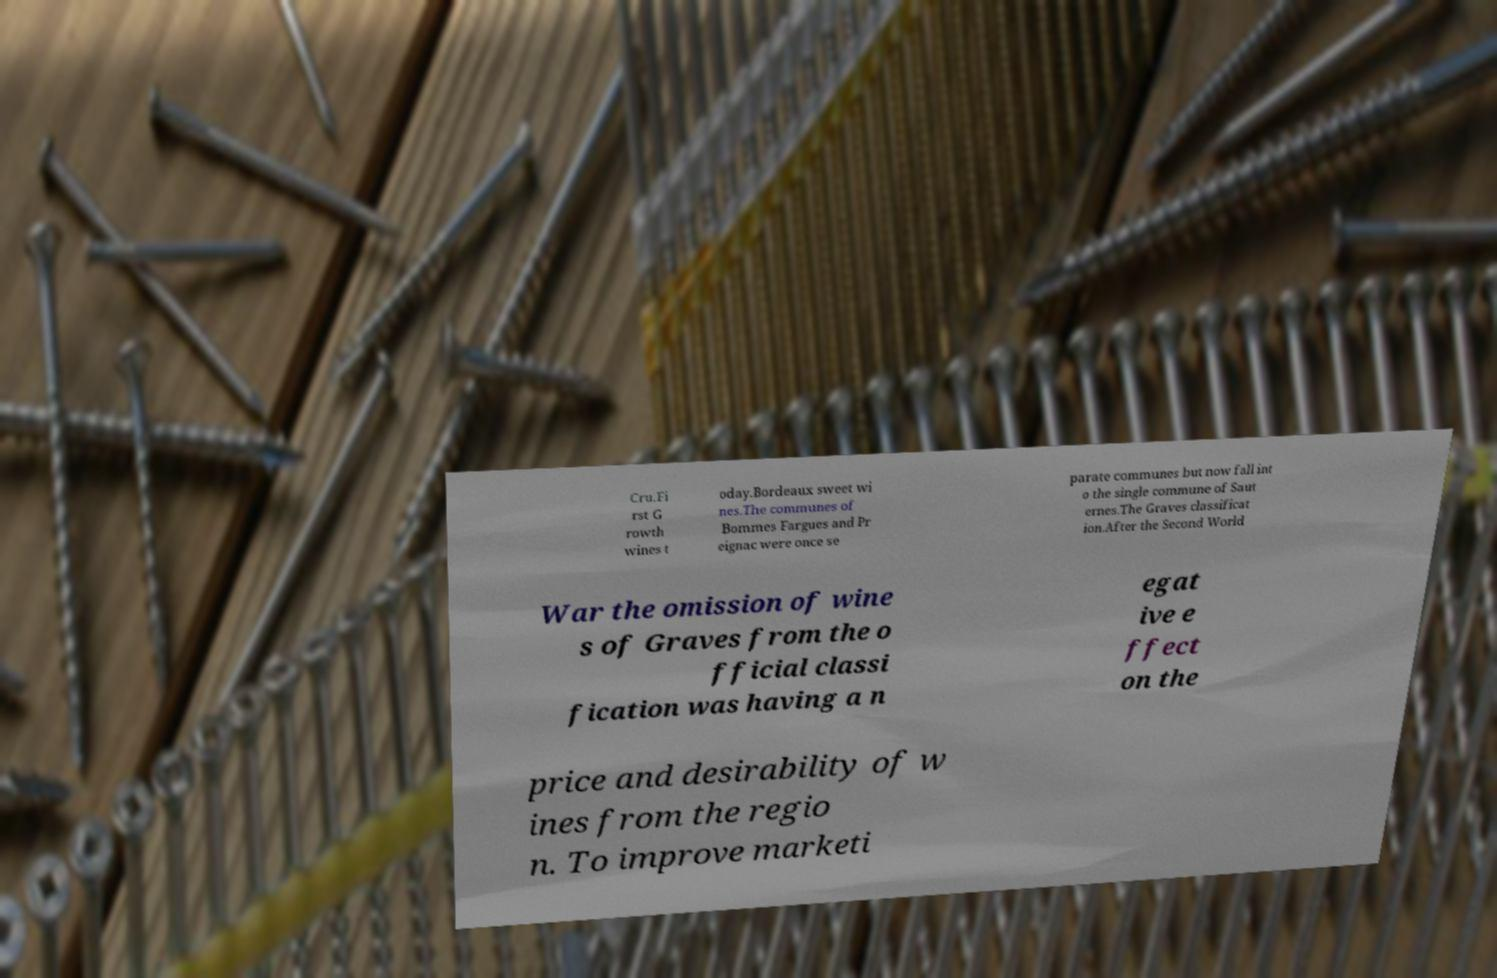Please identify and transcribe the text found in this image. Cru.Fi rst G rowth wines t oday.Bordeaux sweet wi nes.The communes of Bommes Fargues and Pr eignac were once se parate communes but now fall int o the single commune of Saut ernes.The Graves classificat ion.After the Second World War the omission of wine s of Graves from the o fficial classi fication was having a n egat ive e ffect on the price and desirability of w ines from the regio n. To improve marketi 